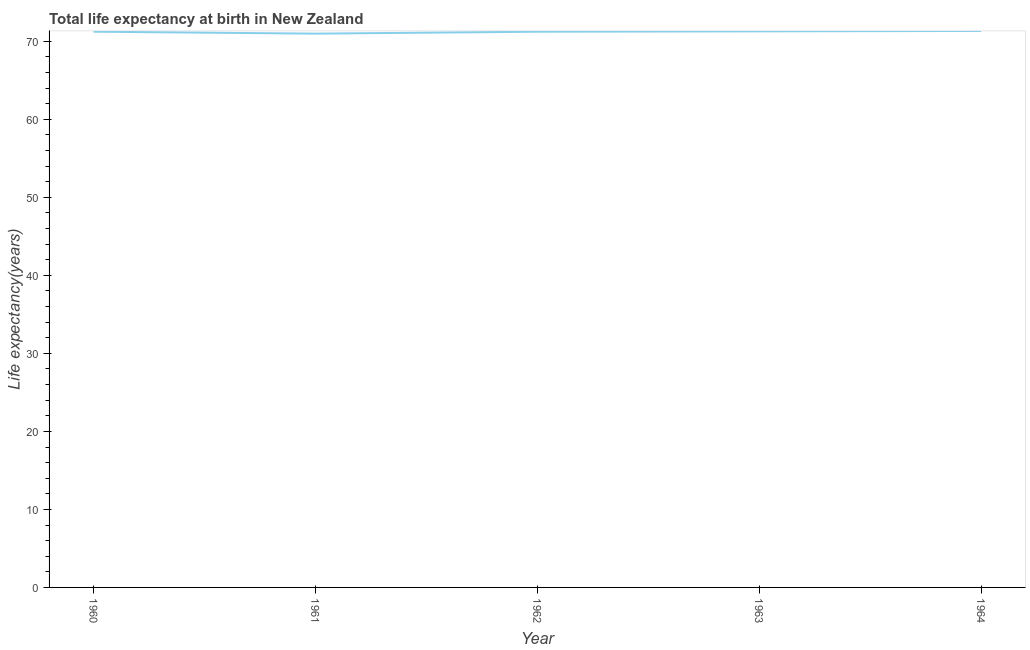What is the life expectancy at birth in 1960?
Your response must be concise. 71.24. Across all years, what is the maximum life expectancy at birth?
Provide a short and direct response. 71.33. Across all years, what is the minimum life expectancy at birth?
Provide a short and direct response. 70.99. In which year was the life expectancy at birth maximum?
Your answer should be compact. 1964. What is the sum of the life expectancy at birth?
Offer a terse response. 356.06. What is the difference between the life expectancy at birth in 1962 and 1964?
Your answer should be compact. -0.1. What is the average life expectancy at birth per year?
Offer a very short reply. 71.21. What is the median life expectancy at birth?
Ensure brevity in your answer.  71.24. In how many years, is the life expectancy at birth greater than 14 years?
Keep it short and to the point. 5. Do a majority of the years between 1961 and 1962 (inclusive) have life expectancy at birth greater than 30 years?
Make the answer very short. Yes. What is the ratio of the life expectancy at birth in 1960 to that in 1961?
Provide a succinct answer. 1. Is the difference between the life expectancy at birth in 1963 and 1964 greater than the difference between any two years?
Offer a terse response. No. What is the difference between the highest and the second highest life expectancy at birth?
Your answer should be compact. 0.05. Is the sum of the life expectancy at birth in 1961 and 1963 greater than the maximum life expectancy at birth across all years?
Give a very brief answer. Yes. What is the difference between the highest and the lowest life expectancy at birth?
Provide a short and direct response. 0.34. In how many years, is the life expectancy at birth greater than the average life expectancy at birth taken over all years?
Your answer should be compact. 4. Does the life expectancy at birth monotonically increase over the years?
Offer a terse response. No. How many lines are there?
Make the answer very short. 1. How many years are there in the graph?
Ensure brevity in your answer.  5. Does the graph contain any zero values?
Your answer should be compact. No. What is the title of the graph?
Provide a short and direct response. Total life expectancy at birth in New Zealand. What is the label or title of the X-axis?
Your answer should be compact. Year. What is the label or title of the Y-axis?
Provide a short and direct response. Life expectancy(years). What is the Life expectancy(years) in 1960?
Your response must be concise. 71.24. What is the Life expectancy(years) in 1961?
Ensure brevity in your answer.  70.99. What is the Life expectancy(years) of 1962?
Your answer should be compact. 71.23. What is the Life expectancy(years) of 1963?
Provide a succinct answer. 71.28. What is the Life expectancy(years) of 1964?
Provide a short and direct response. 71.33. What is the difference between the Life expectancy(years) in 1960 and 1961?
Provide a succinct answer. 0.25. What is the difference between the Life expectancy(years) in 1960 and 1962?
Make the answer very short. 0. What is the difference between the Life expectancy(years) in 1960 and 1963?
Your answer should be compact. -0.04. What is the difference between the Life expectancy(years) in 1960 and 1964?
Give a very brief answer. -0.09. What is the difference between the Life expectancy(years) in 1961 and 1962?
Provide a succinct answer. -0.25. What is the difference between the Life expectancy(years) in 1961 and 1963?
Offer a very short reply. -0.3. What is the difference between the Life expectancy(years) in 1961 and 1964?
Your answer should be very brief. -0.34. What is the difference between the Life expectancy(years) in 1962 and 1963?
Offer a terse response. -0.05. What is the difference between the Life expectancy(years) in 1962 and 1964?
Make the answer very short. -0.1. What is the difference between the Life expectancy(years) in 1963 and 1964?
Offer a terse response. -0.05. What is the ratio of the Life expectancy(years) in 1960 to that in 1962?
Your answer should be compact. 1. What is the ratio of the Life expectancy(years) in 1960 to that in 1963?
Your answer should be compact. 1. What is the ratio of the Life expectancy(years) in 1961 to that in 1962?
Your answer should be very brief. 1. What is the ratio of the Life expectancy(years) in 1961 to that in 1963?
Give a very brief answer. 1. What is the ratio of the Life expectancy(years) in 1961 to that in 1964?
Offer a very short reply. 0.99. 